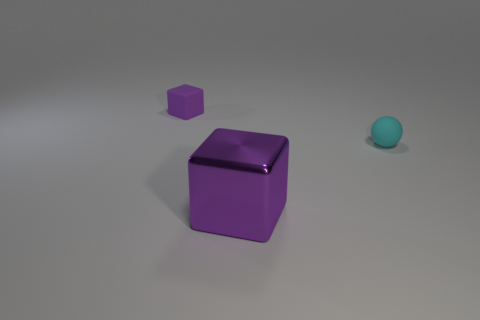Does the large shiny object have the same color as the small cube?
Offer a very short reply. Yes. There is another object that is the same size as the cyan thing; what shape is it?
Your answer should be compact. Cube. The purple matte object is what size?
Offer a terse response. Small. There is a rubber object on the left side of the big purple cube; is it the same size as the purple thing in front of the cyan rubber object?
Your response must be concise. No. What color is the rubber object that is in front of the purple thing behind the cyan rubber ball?
Keep it short and to the point. Cyan. How many shiny things are either purple things or tiny purple blocks?
Make the answer very short. 1. There is a object that is both behind the big purple cube and on the left side of the small cyan rubber object; what color is it?
Ensure brevity in your answer.  Purple. There is a tiny block; how many purple metal blocks are in front of it?
Your response must be concise. 1. What material is the big purple cube?
Make the answer very short. Metal. The thing that is in front of the matte thing to the right of the small block behind the sphere is what color?
Provide a short and direct response. Purple. 